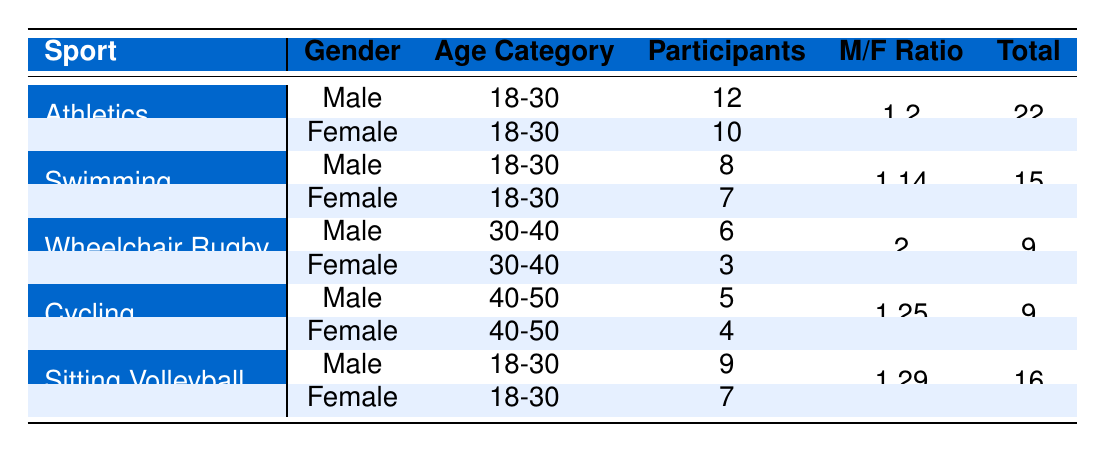What is the total number of male participants in Athletics? From the table, the number of male participants in Athletics is listed as 12.
Answer: 12 What is the number of female participants in Wheelchair Rugby? The table indicates that the number of female participants in Wheelchair Rugby is 3.
Answer: 3 Which sport has the highest number of male participants in the age category 18-30? Comparing Athletics (12), Swimming (8), and Sitting Volleyball (9), Athletics has the highest number with 12 participants in the 18-30 age category.
Answer: Athletics What is the difference in total participants between the two genders in Swimming? For Swimming, the total participants by gender are 8 males and 7 females. The difference is 8 - 7 = 1.
Answer: 1 Is the male to female ratio in Cycling greater than 1? The ratio for Cycling is calculated as 5 males and 4 females, which gives a ratio of 5/4 = 1.25. Since 1.25 is greater than 1, the statement is true.
Answer: Yes If you aggregate the total number of participants across all age categories in Athletics, how many are there? The total number of participants in Athletics is calculated by adding 12 (men) + 10 (women) = 22 in the 18-30 age category and no other age categories listed for Athletics. Thus, the total remains 22.
Answer: 22 Which sport has the least number of female participants overall? The table shows 10 females in Athletics, 7 in Swimming, 3 in Wheelchair Rugby, 4 in Cycling, and 7 in Sitting Volleyball. Wheelchair Rugby has the least with 3 female participants.
Answer: Wheelchair Rugby What is the average number of participants for males across all listed sports? The total number of male participants is 12 (Athletics) + 8 (Swimming) + 6 (Wheelchair Rugby) + 5 (Cycling) + 9 (Sitting Volleyball) = 40. There are 5 sports, so the average is 40 / 5 = 8.
Answer: 8 How many more male participants are there in Sitting Volleyball compared to Swimming? Sitting Volleyball has 9 male participants and Swimming has 8, so the difference is 9 - 8 = 1.
Answer: 1 